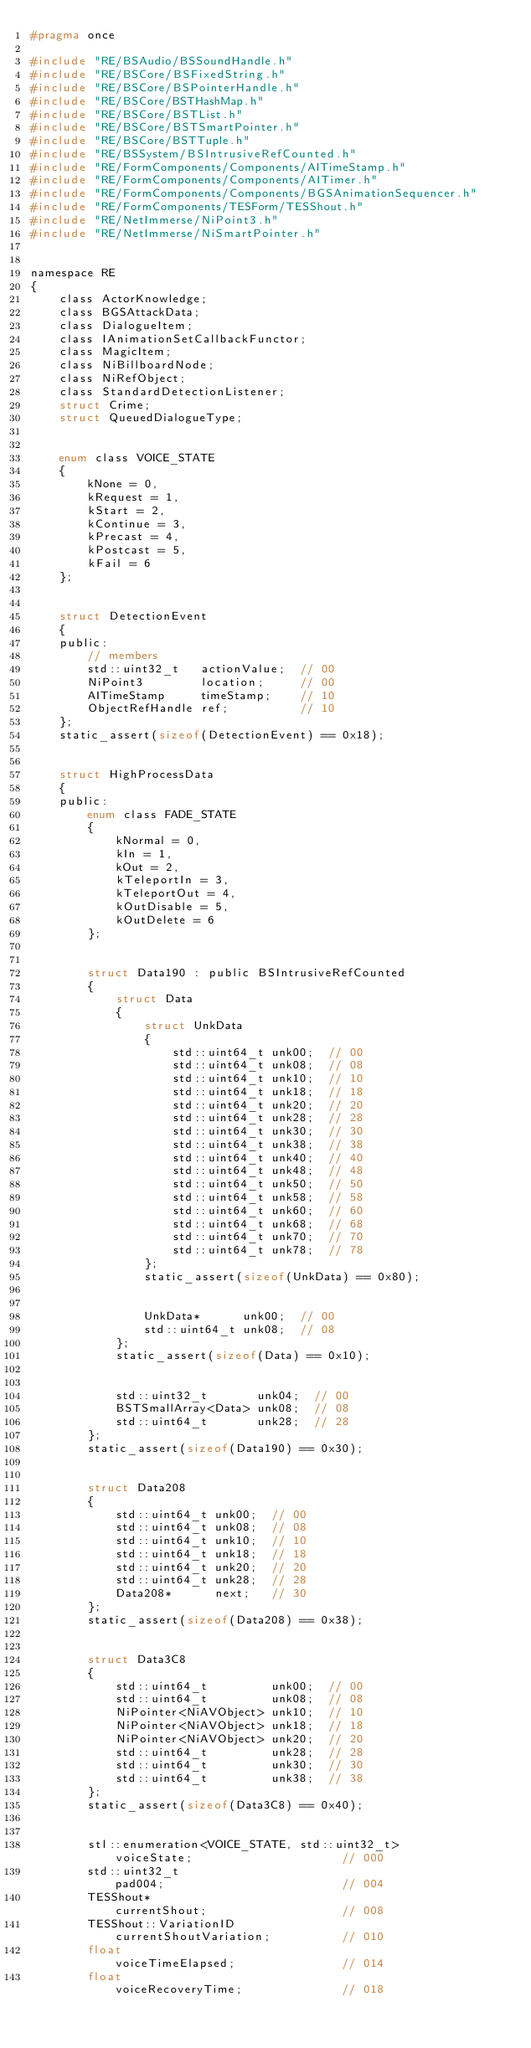Convert code to text. <code><loc_0><loc_0><loc_500><loc_500><_C_>#pragma once

#include "RE/BSAudio/BSSoundHandle.h"
#include "RE/BSCore/BSFixedString.h"
#include "RE/BSCore/BSPointerHandle.h"
#include "RE/BSCore/BSTHashMap.h"
#include "RE/BSCore/BSTList.h"
#include "RE/BSCore/BSTSmartPointer.h"
#include "RE/BSCore/BSTTuple.h"
#include "RE/BSSystem/BSIntrusiveRefCounted.h"
#include "RE/FormComponents/Components/AITimeStamp.h"
#include "RE/FormComponents/Components/AITimer.h"
#include "RE/FormComponents/Components/BGSAnimationSequencer.h"
#include "RE/FormComponents/TESForm/TESShout.h"
#include "RE/NetImmerse/NiPoint3.h"
#include "RE/NetImmerse/NiSmartPointer.h"


namespace RE
{
	class ActorKnowledge;
	class BGSAttackData;
	class DialogueItem;
	class IAnimationSetCallbackFunctor;
	class MagicItem;
	class NiBillboardNode;
	class NiRefObject;
	class StandardDetectionListener;
	struct Crime;
	struct QueuedDialogueType;


	enum class VOICE_STATE
	{
		kNone = 0,
		kRequest = 1,
		kStart = 2,
		kContinue = 3,
		kPrecast = 4,
		kPostcast = 5,
		kFail = 6
	};


	struct DetectionEvent
	{
	public:
		// members
		std::uint32_t	actionValue;  // 00
		NiPoint3		location;	  // 00
		AITimeStamp		timeStamp;	  // 10
		ObjectRefHandle ref;		  // 10
	};
	static_assert(sizeof(DetectionEvent) == 0x18);


	struct HighProcessData
	{
	public:
		enum class FADE_STATE
		{
			kNormal = 0,
			kIn = 1,
			kOut = 2,
			kTeleportIn = 3,
			kTeleportOut = 4,
			kOutDisable = 5,
			kOutDelete = 6
		};


		struct Data190 : public BSIntrusiveRefCounted
		{
			struct Data
			{
				struct UnkData
				{
					std::uint64_t unk00;  // 00
					std::uint64_t unk08;  // 08
					std::uint64_t unk10;  // 10
					std::uint64_t unk18;  // 18
					std::uint64_t unk20;  // 20
					std::uint64_t unk28;  // 28
					std::uint64_t unk30;  // 30
					std::uint64_t unk38;  // 38
					std::uint64_t unk40;  // 40
					std::uint64_t unk48;  // 48
					std::uint64_t unk50;  // 50
					std::uint64_t unk58;  // 58
					std::uint64_t unk60;  // 60
					std::uint64_t unk68;  // 68
					std::uint64_t unk70;  // 70
					std::uint64_t unk78;  // 78
				};
				static_assert(sizeof(UnkData) == 0x80);


				UnkData*	  unk00;  // 00
				std::uint64_t unk08;  // 08
			};
			static_assert(sizeof(Data) == 0x10);


			std::uint32_t		unk04;	// 00
			BSTSmallArray<Data> unk08;	// 08
			std::uint64_t		unk28;	// 28
		};
		static_assert(sizeof(Data190) == 0x30);


		struct Data208
		{
			std::uint64_t unk00;  // 00
			std::uint64_t unk08;  // 08
			std::uint64_t unk10;  // 10
			std::uint64_t unk18;  // 18
			std::uint64_t unk20;  // 20
			std::uint64_t unk28;  // 28
			Data208*	  next;	  // 30
		};
		static_assert(sizeof(Data208) == 0x38);


		struct Data3C8
		{
			std::uint64_t		  unk00;  // 00
			std::uint64_t		  unk08;  // 08
			NiPointer<NiAVObject> unk10;  // 10
			NiPointer<NiAVObject> unk18;  // 18
			NiPointer<NiAVObject> unk20;  // 20
			std::uint64_t		  unk28;  // 28
			std::uint64_t		  unk30;  // 30
			std::uint64_t		  unk38;  // 38
		};
		static_assert(sizeof(Data3C8) == 0x40);


		stl::enumeration<VOICE_STATE, std::uint32_t>		  voiceState;					  // 000
		std::uint32_t										  pad004;						  // 004
		TESShout*											  currentShout;					  // 008
		TESShout::VariationID								  currentShoutVariation;		  // 010
		float												  voiceTimeElapsed;				  // 014
		float												  voiceRecoveryTime;			  // 018</code> 